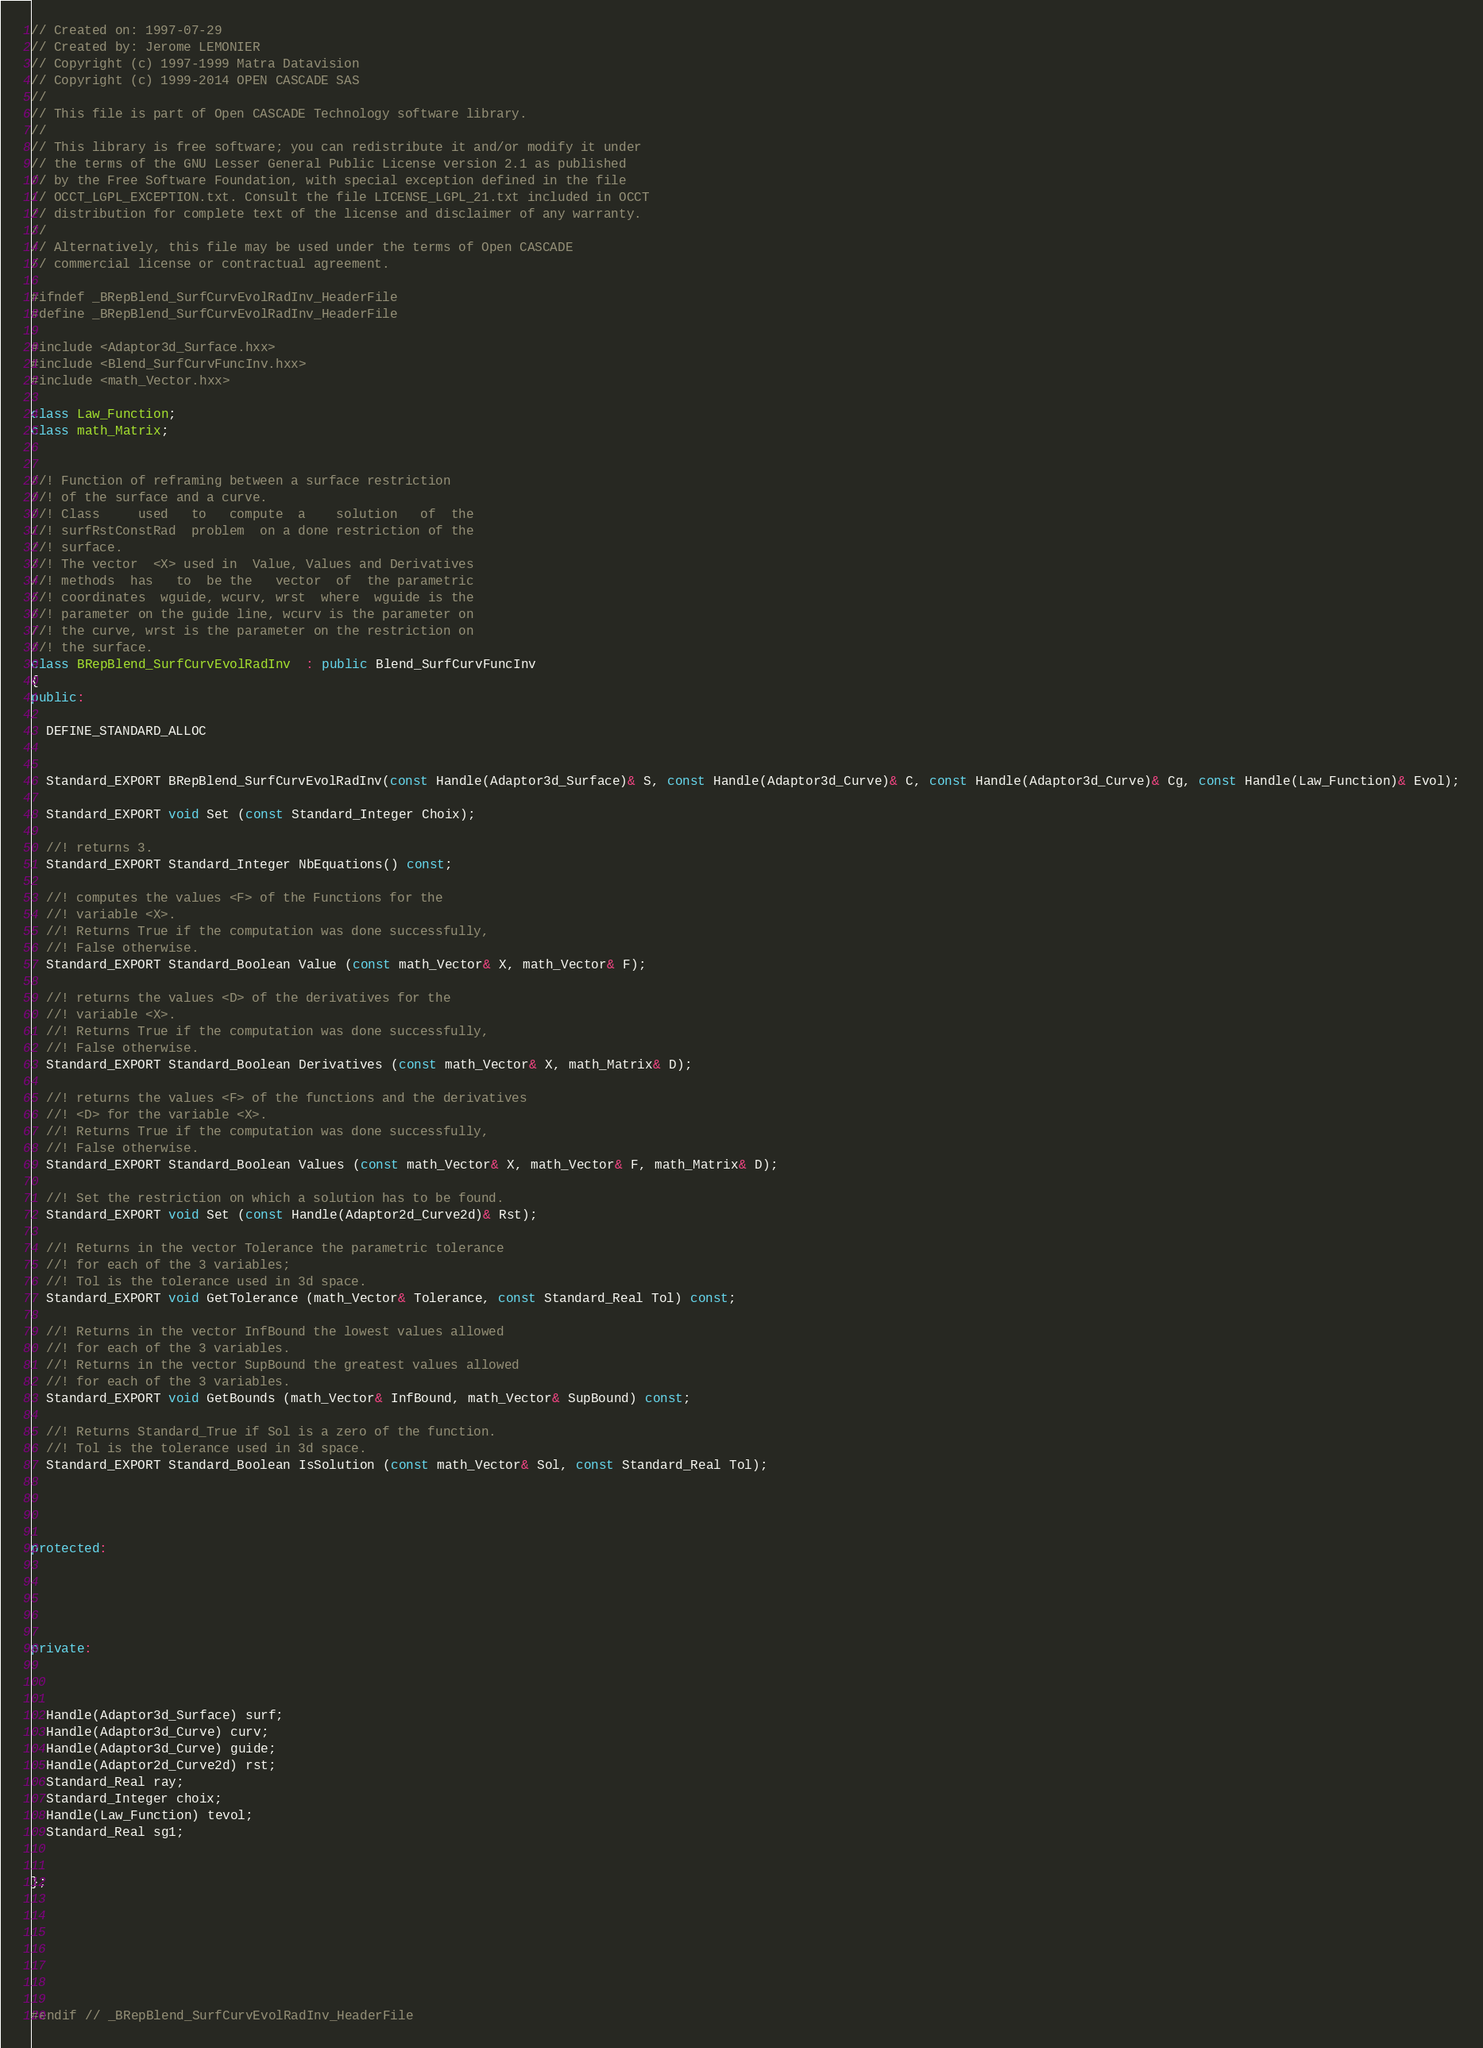<code> <loc_0><loc_0><loc_500><loc_500><_C++_>// Created on: 1997-07-29
// Created by: Jerome LEMONIER
// Copyright (c) 1997-1999 Matra Datavision
// Copyright (c) 1999-2014 OPEN CASCADE SAS
//
// This file is part of Open CASCADE Technology software library.
//
// This library is free software; you can redistribute it and/or modify it under
// the terms of the GNU Lesser General Public License version 2.1 as published
// by the Free Software Foundation, with special exception defined in the file
// OCCT_LGPL_EXCEPTION.txt. Consult the file LICENSE_LGPL_21.txt included in OCCT
// distribution for complete text of the license and disclaimer of any warranty.
//
// Alternatively, this file may be used under the terms of Open CASCADE
// commercial license or contractual agreement.

#ifndef _BRepBlend_SurfCurvEvolRadInv_HeaderFile
#define _BRepBlend_SurfCurvEvolRadInv_HeaderFile

#include <Adaptor3d_Surface.hxx>
#include <Blend_SurfCurvFuncInv.hxx>
#include <math_Vector.hxx>

class Law_Function;
class math_Matrix;


//! Function of reframing between a surface restriction
//! of the surface and a curve.
//! Class     used   to   compute  a    solution   of  the
//! surfRstConstRad  problem  on a done restriction of the
//! surface.
//! The vector  <X> used in  Value, Values and Derivatives
//! methods  has   to  be the   vector  of  the parametric
//! coordinates  wguide, wcurv, wrst  where  wguide is the
//! parameter on the guide line, wcurv is the parameter on
//! the curve, wrst is the parameter on the restriction on
//! the surface.
class BRepBlend_SurfCurvEvolRadInv  : public Blend_SurfCurvFuncInv
{
public:

  DEFINE_STANDARD_ALLOC

  
  Standard_EXPORT BRepBlend_SurfCurvEvolRadInv(const Handle(Adaptor3d_Surface)& S, const Handle(Adaptor3d_Curve)& C, const Handle(Adaptor3d_Curve)& Cg, const Handle(Law_Function)& Evol);
  
  Standard_EXPORT void Set (const Standard_Integer Choix);
  
  //! returns 3.
  Standard_EXPORT Standard_Integer NbEquations() const;
  
  //! computes the values <F> of the Functions for the
  //! variable <X>.
  //! Returns True if the computation was done successfully,
  //! False otherwise.
  Standard_EXPORT Standard_Boolean Value (const math_Vector& X, math_Vector& F);
  
  //! returns the values <D> of the derivatives for the
  //! variable <X>.
  //! Returns True if the computation was done successfully,
  //! False otherwise.
  Standard_EXPORT Standard_Boolean Derivatives (const math_Vector& X, math_Matrix& D);
  
  //! returns the values <F> of the functions and the derivatives
  //! <D> for the variable <X>.
  //! Returns True if the computation was done successfully,
  //! False otherwise.
  Standard_EXPORT Standard_Boolean Values (const math_Vector& X, math_Vector& F, math_Matrix& D);
  
  //! Set the restriction on which a solution has to be found.
  Standard_EXPORT void Set (const Handle(Adaptor2d_Curve2d)& Rst);
  
  //! Returns in the vector Tolerance the parametric tolerance
  //! for each of the 3 variables;
  //! Tol is the tolerance used in 3d space.
  Standard_EXPORT void GetTolerance (math_Vector& Tolerance, const Standard_Real Tol) const;
  
  //! Returns in the vector InfBound the lowest values allowed
  //! for each of the 3 variables.
  //! Returns in the vector SupBound the greatest values allowed
  //! for each of the 3 variables.
  Standard_EXPORT void GetBounds (math_Vector& InfBound, math_Vector& SupBound) const;
  
  //! Returns Standard_True if Sol is a zero of the function.
  //! Tol is the tolerance used in 3d space.
  Standard_EXPORT Standard_Boolean IsSolution (const math_Vector& Sol, const Standard_Real Tol);




protected:





private:



  Handle(Adaptor3d_Surface) surf;
  Handle(Adaptor3d_Curve) curv;
  Handle(Adaptor3d_Curve) guide;
  Handle(Adaptor2d_Curve2d) rst;
  Standard_Real ray;
  Standard_Integer choix;
  Handle(Law_Function) tevol;
  Standard_Real sg1;


};







#endif // _BRepBlend_SurfCurvEvolRadInv_HeaderFile
</code> 